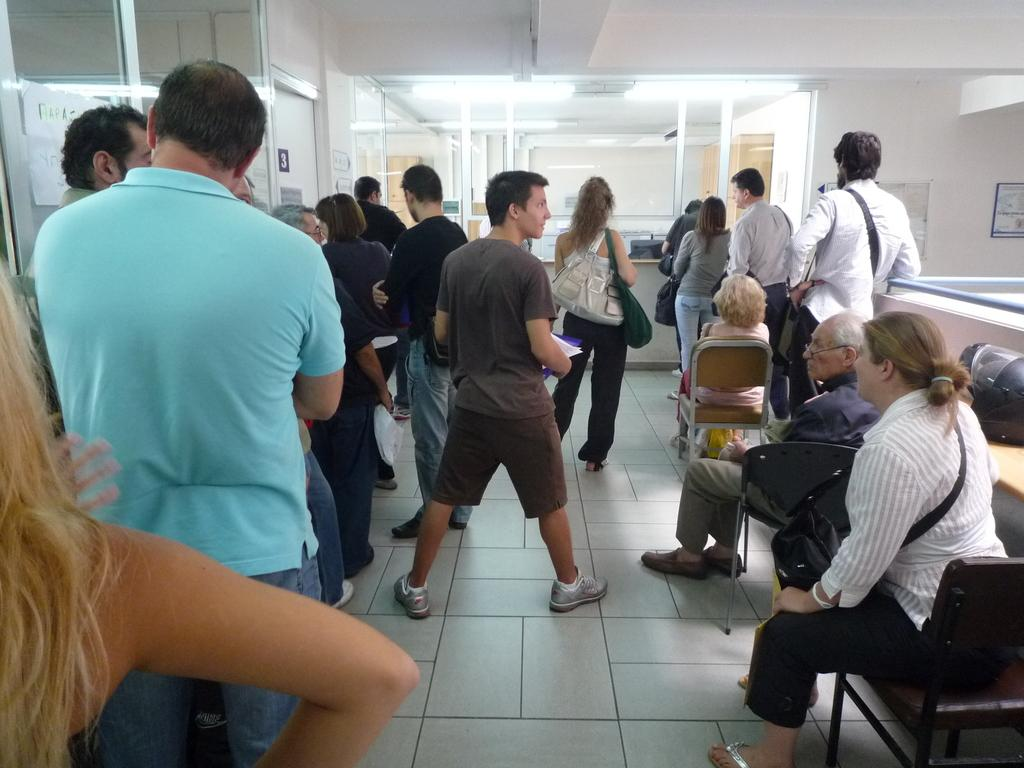How many people are visible in the image? There are many people in the image. What are some of the people doing in the image? Some people are sitting on chairs. What can be seen in the background of the image? There are glass walls in the background. What is on the wall on the right side of the image? There is a wall on the right side with something pasted on it. What type of clouds can be seen in the image? There are no clouds visible in the image. Are there any fowl present in the image? There is no mention of fowl in the provided facts, so we cannot determine if any are present in the image. 